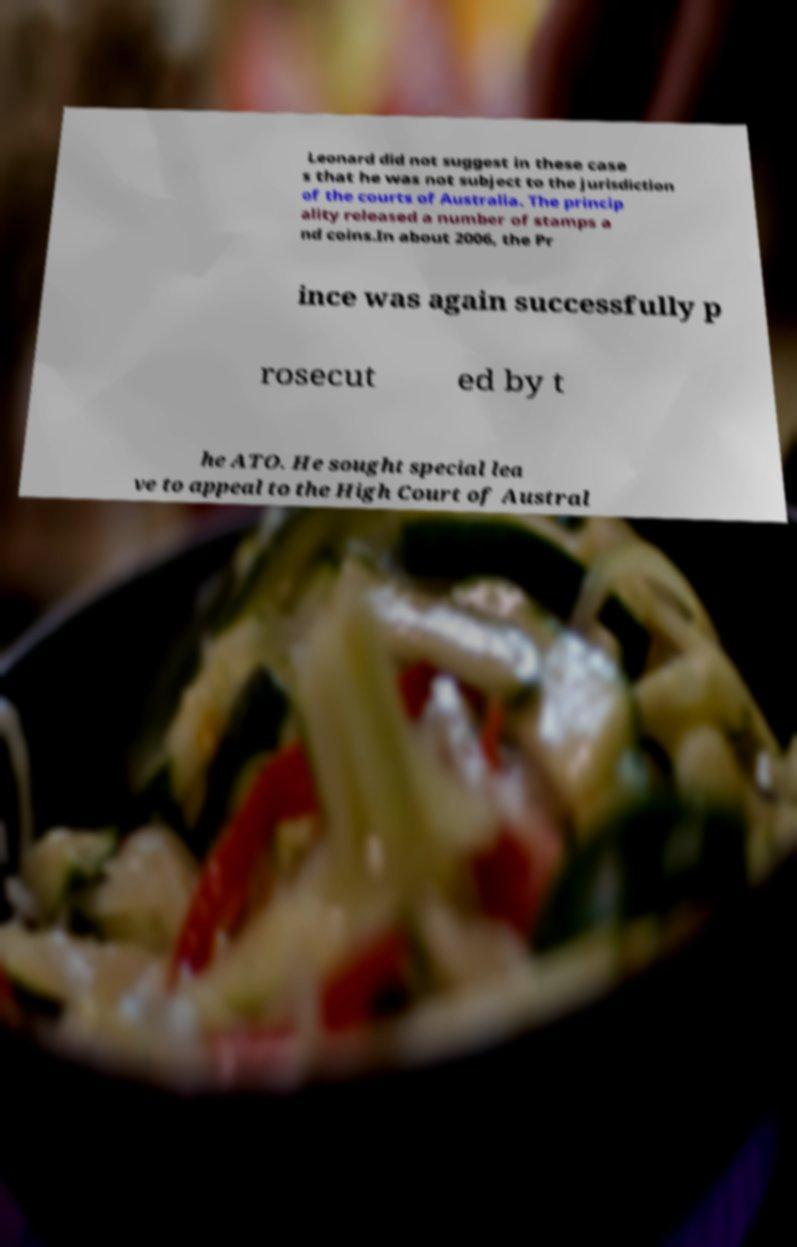Can you read and provide the text displayed in the image?This photo seems to have some interesting text. Can you extract and type it out for me? Leonard did not suggest in these case s that he was not subject to the jurisdiction of the courts of Australia. The princip ality released a number of stamps a nd coins.In about 2006, the Pr ince was again successfully p rosecut ed by t he ATO. He sought special lea ve to appeal to the High Court of Austral 